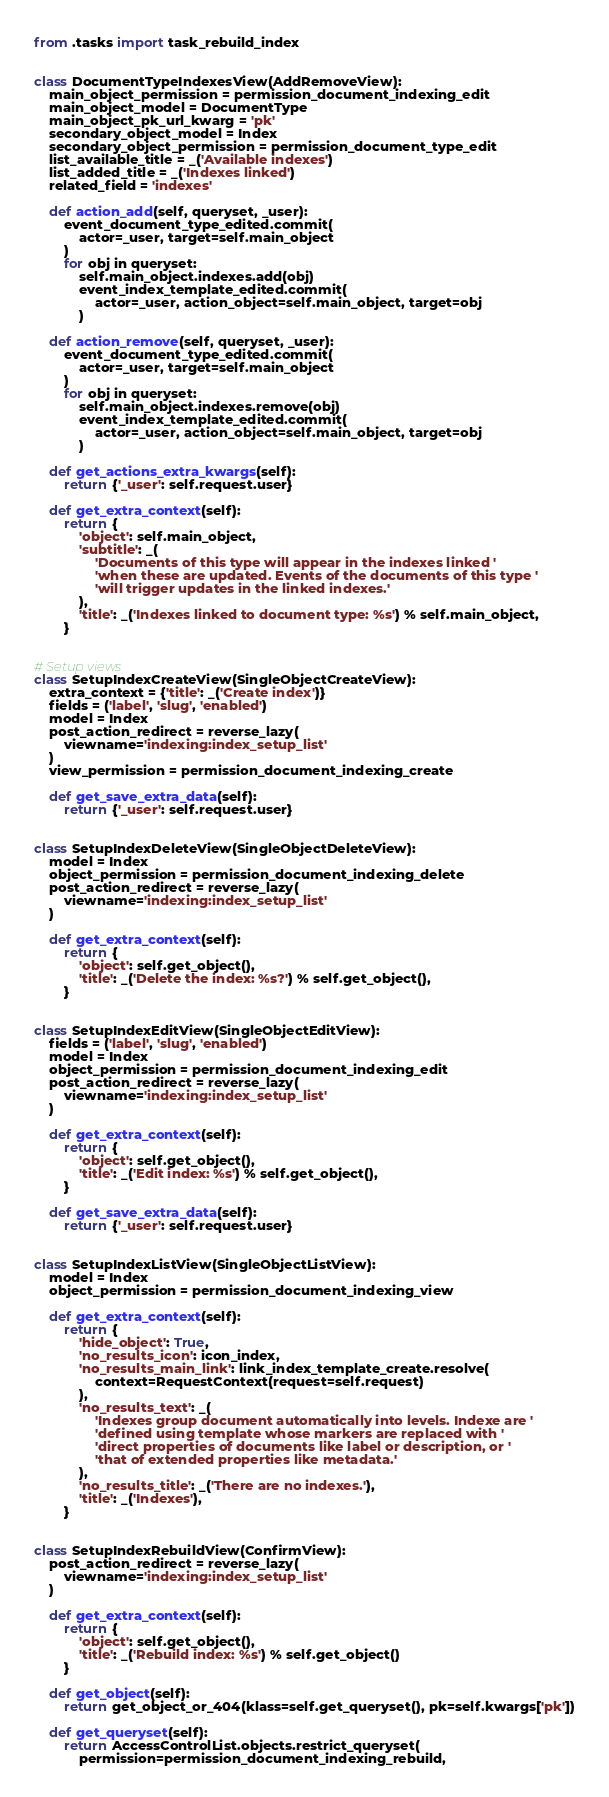<code> <loc_0><loc_0><loc_500><loc_500><_Python_>from .tasks import task_rebuild_index


class DocumentTypeIndexesView(AddRemoveView):
    main_object_permission = permission_document_indexing_edit
    main_object_model = DocumentType
    main_object_pk_url_kwarg = 'pk'
    secondary_object_model = Index
    secondary_object_permission = permission_document_type_edit
    list_available_title = _('Available indexes')
    list_added_title = _('Indexes linked')
    related_field = 'indexes'

    def action_add(self, queryset, _user):
        event_document_type_edited.commit(
            actor=_user, target=self.main_object
        )
        for obj in queryset:
            self.main_object.indexes.add(obj)
            event_index_template_edited.commit(
                actor=_user, action_object=self.main_object, target=obj
            )

    def action_remove(self, queryset, _user):
        event_document_type_edited.commit(
            actor=_user, target=self.main_object
        )
        for obj in queryset:
            self.main_object.indexes.remove(obj)
            event_index_template_edited.commit(
                actor=_user, action_object=self.main_object, target=obj
            )

    def get_actions_extra_kwargs(self):
        return {'_user': self.request.user}

    def get_extra_context(self):
        return {
            'object': self.main_object,
            'subtitle': _(
                'Documents of this type will appear in the indexes linked '
                'when these are updated. Events of the documents of this type '
                'will trigger updates in the linked indexes.'
            ),
            'title': _('Indexes linked to document type: %s') % self.main_object,
        }


# Setup views
class SetupIndexCreateView(SingleObjectCreateView):
    extra_context = {'title': _('Create index')}
    fields = ('label', 'slug', 'enabled')
    model = Index
    post_action_redirect = reverse_lazy(
        viewname='indexing:index_setup_list'
    )
    view_permission = permission_document_indexing_create

    def get_save_extra_data(self):
        return {'_user': self.request.user}


class SetupIndexDeleteView(SingleObjectDeleteView):
    model = Index
    object_permission = permission_document_indexing_delete
    post_action_redirect = reverse_lazy(
        viewname='indexing:index_setup_list'
    )

    def get_extra_context(self):
        return {
            'object': self.get_object(),
            'title': _('Delete the index: %s?') % self.get_object(),
        }


class SetupIndexEditView(SingleObjectEditView):
    fields = ('label', 'slug', 'enabled')
    model = Index
    object_permission = permission_document_indexing_edit
    post_action_redirect = reverse_lazy(
        viewname='indexing:index_setup_list'
    )

    def get_extra_context(self):
        return {
            'object': self.get_object(),
            'title': _('Edit index: %s') % self.get_object(),
        }

    def get_save_extra_data(self):
        return {'_user': self.request.user}


class SetupIndexListView(SingleObjectListView):
    model = Index
    object_permission = permission_document_indexing_view

    def get_extra_context(self):
        return {
            'hide_object': True,
            'no_results_icon': icon_index,
            'no_results_main_link': link_index_template_create.resolve(
                context=RequestContext(request=self.request)
            ),
            'no_results_text': _(
                'Indexes group document automatically into levels. Indexe are '
                'defined using template whose markers are replaced with '
                'direct properties of documents like label or description, or '
                'that of extended properties like metadata.'
            ),
            'no_results_title': _('There are no indexes.'),
            'title': _('Indexes'),
        }


class SetupIndexRebuildView(ConfirmView):
    post_action_redirect = reverse_lazy(
        viewname='indexing:index_setup_list'
    )

    def get_extra_context(self):
        return {
            'object': self.get_object(),
            'title': _('Rebuild index: %s') % self.get_object()
        }

    def get_object(self):
        return get_object_or_404(klass=self.get_queryset(), pk=self.kwargs['pk'])

    def get_queryset(self):
        return AccessControlList.objects.restrict_queryset(
            permission=permission_document_indexing_rebuild,</code> 